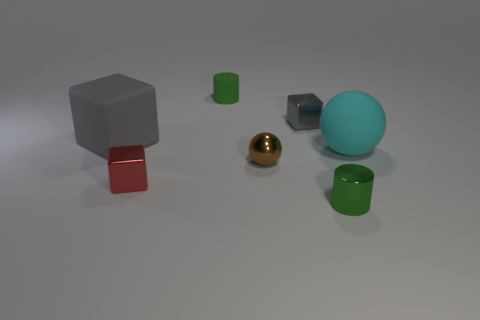What is the texture of the objects present in the image? The textures of objects in the image vary. The cube and cylinders appear to have a smooth, matte finish. The shiny ball is reflective, whereas the smaller cube and the other ball have a slightly duller finish, suggesting a more diffuse reflection. 